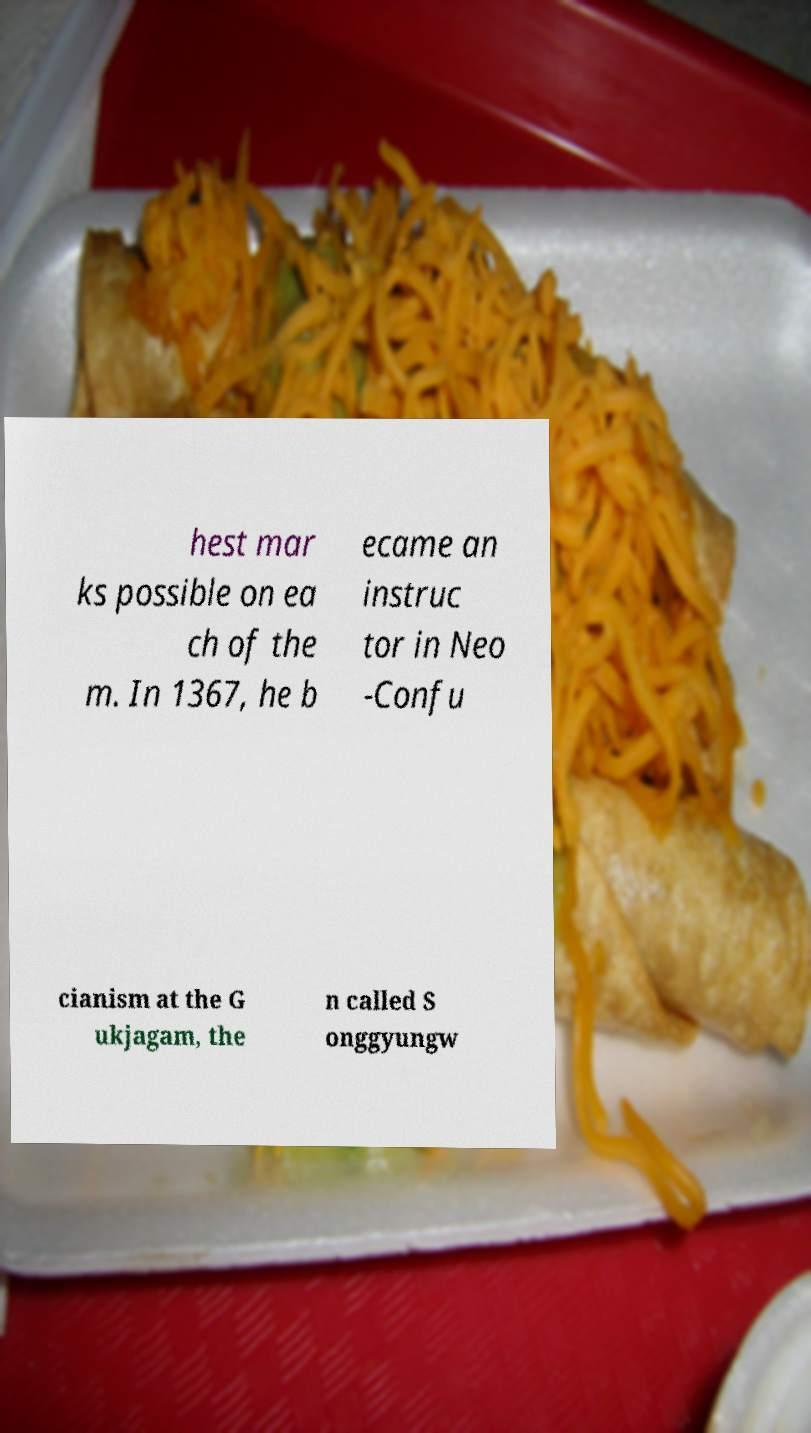Could you extract and type out the text from this image? hest mar ks possible on ea ch of the m. In 1367, he b ecame an instruc tor in Neo -Confu cianism at the G ukjagam, the n called S onggyungw 